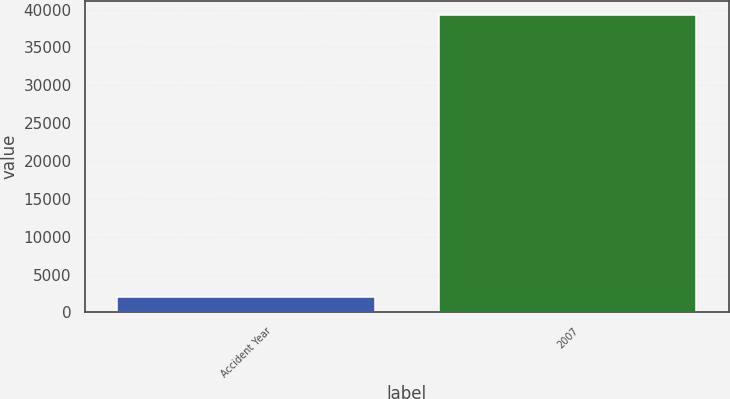<chart> <loc_0><loc_0><loc_500><loc_500><bar_chart><fcel>Accident Year<fcel>2007<nl><fcel>2011<fcel>39212<nl></chart> 